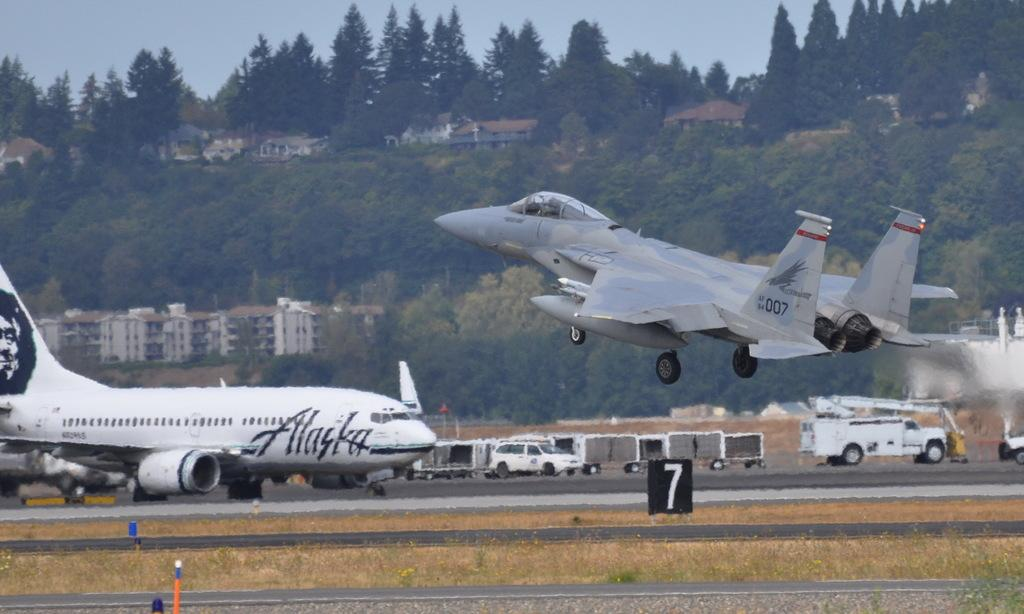<image>
Create a compact narrative representing the image presented. An Alaska plane is grounded as a jet takes off. 